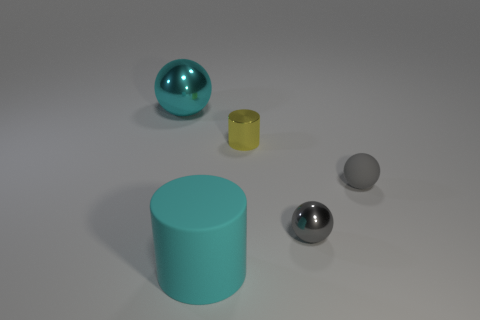There is a large object in front of the shiny cylinder; what is its color?
Keep it short and to the point. Cyan. Does the cyan cylinder have the same size as the gray thing that is behind the tiny gray shiny object?
Keep it short and to the point. No. How big is the ball that is on the left side of the gray rubber object and right of the large cyan shiny thing?
Make the answer very short. Small. Are there any other large balls made of the same material as the big cyan sphere?
Offer a terse response. No. The tiny yellow thing has what shape?
Offer a terse response. Cylinder. Does the yellow cylinder have the same size as the gray shiny thing?
Provide a short and direct response. Yes. How many other objects are there of the same shape as the tiny gray rubber object?
Keep it short and to the point. 2. The small shiny object behind the gray matte object has what shape?
Offer a terse response. Cylinder. Does the metal thing in front of the yellow metal thing have the same shape as the large thing in front of the large metallic ball?
Ensure brevity in your answer.  No. Are there an equal number of yellow cylinders behind the yellow thing and tiny spheres?
Offer a very short reply. No. 